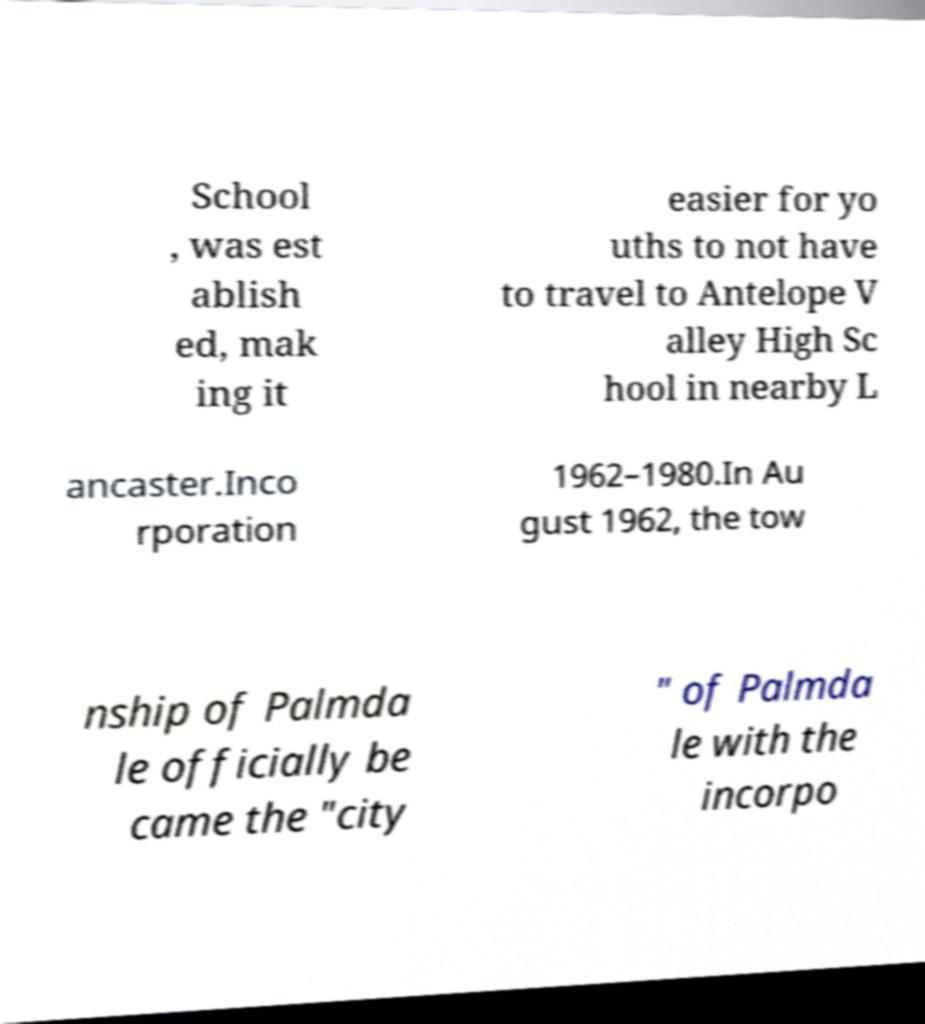What messages or text are displayed in this image? I need them in a readable, typed format. School , was est ablish ed, mak ing it easier for yo uths to not have to travel to Antelope V alley High Sc hool in nearby L ancaster.Inco rporation 1962–1980.In Au gust 1962, the tow nship of Palmda le officially be came the "city " of Palmda le with the incorpo 